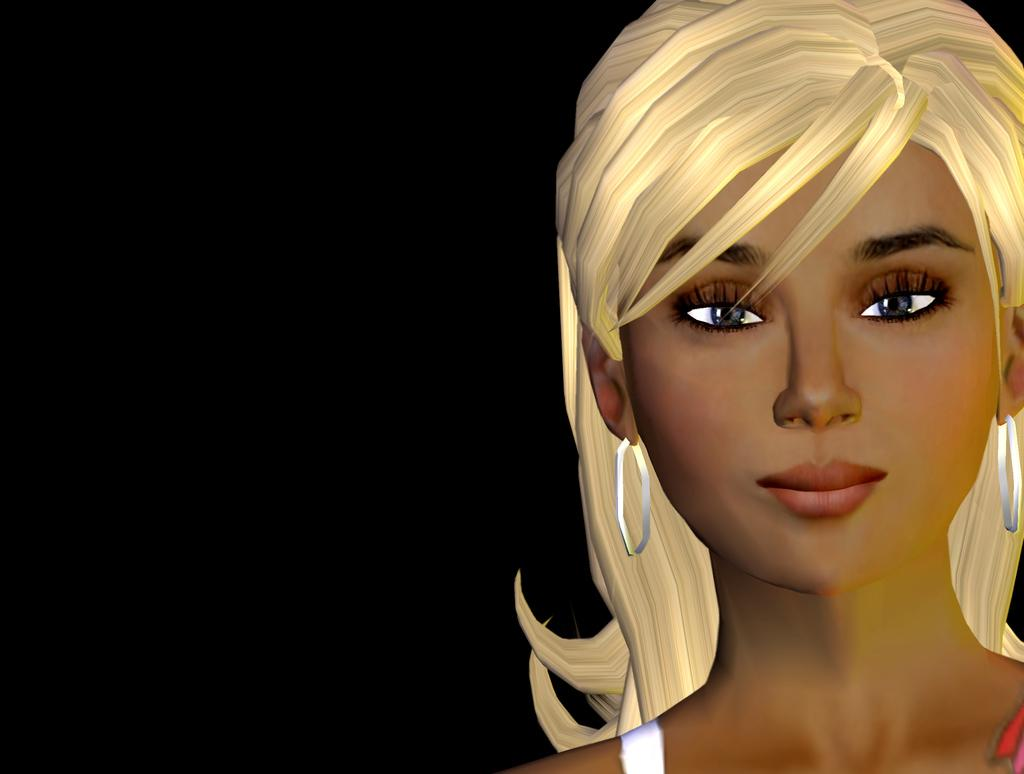What style is used in the image? The image is a cartoon. Who are the characters in the image? There are women in the image. What type of development is taking place in the image? There is no development taking place in the image; it is a static cartoon featuring women. Can you see a goat in the image? No, there is no goat present in the image. 